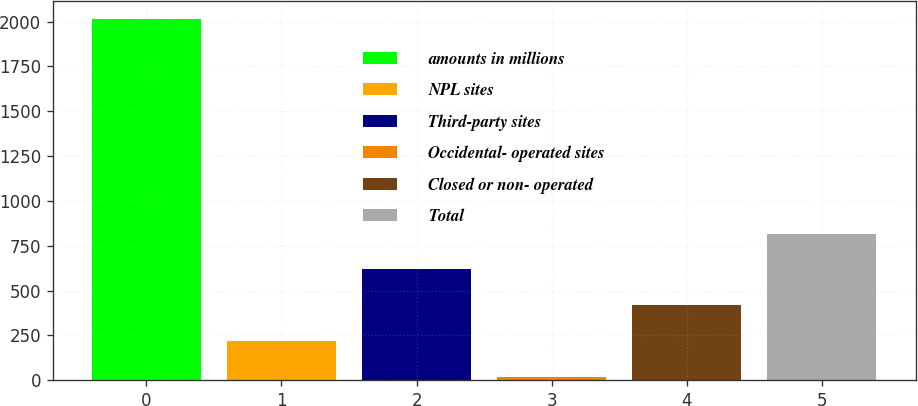Convert chart. <chart><loc_0><loc_0><loc_500><loc_500><bar_chart><fcel>amounts in millions<fcel>NPL sites<fcel>Third-party sites<fcel>Occidental- operated sites<fcel>Closed or non- operated<fcel>Total<nl><fcel>2013<fcel>219.3<fcel>617.9<fcel>20<fcel>418.6<fcel>817.2<nl></chart> 